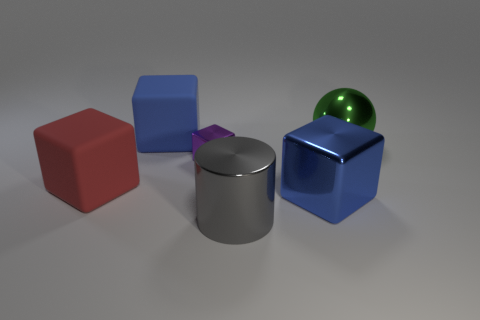What is the shape of the large metallic thing that is both behind the gray cylinder and in front of the small shiny cube?
Provide a succinct answer. Cube. Are there an equal number of large rubber blocks that are on the left side of the blue rubber thing and matte blocks on the right side of the tiny cube?
Your answer should be compact. No. What number of spheres are either large green metal objects or gray things?
Keep it short and to the point. 1. How many tiny purple cubes are the same material as the large red block?
Your answer should be very brief. 0. What is the shape of the thing that is the same color as the big shiny block?
Ensure brevity in your answer.  Cube. What is the big cube that is in front of the big green metallic thing and to the left of the large metal block made of?
Your answer should be very brief. Rubber. What shape is the small purple object that is behind the red matte thing?
Make the answer very short. Cube. There is a green thing on the right side of the large blue block behind the purple thing; what is its shape?
Ensure brevity in your answer.  Sphere. Are there any big green metallic things that have the same shape as the big red object?
Keep it short and to the point. No. The green object that is the same size as the blue rubber block is what shape?
Ensure brevity in your answer.  Sphere. 